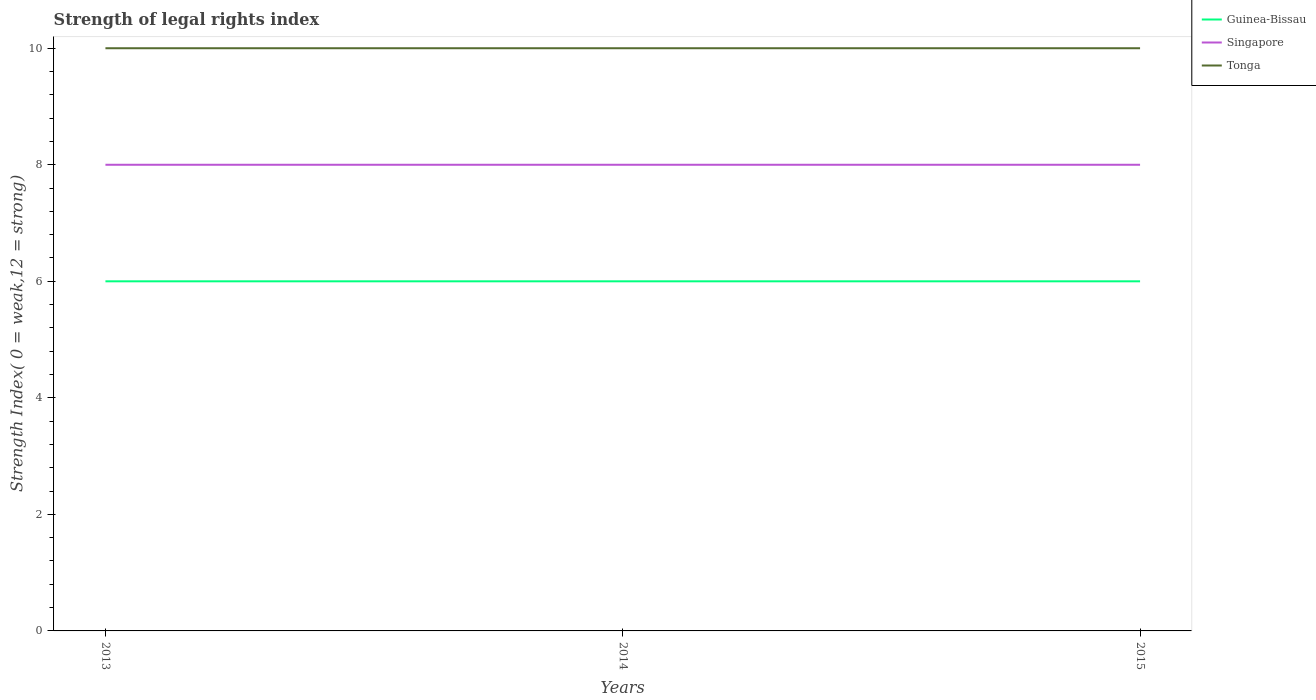Does the line corresponding to Singapore intersect with the line corresponding to Tonga?
Provide a succinct answer. No. Is the number of lines equal to the number of legend labels?
Your answer should be very brief. Yes. What is the difference between the highest and the lowest strength index in Tonga?
Give a very brief answer. 0. Is the strength index in Singapore strictly greater than the strength index in Guinea-Bissau over the years?
Ensure brevity in your answer.  No. What is the difference between two consecutive major ticks on the Y-axis?
Keep it short and to the point. 2. Are the values on the major ticks of Y-axis written in scientific E-notation?
Provide a short and direct response. No. Does the graph contain any zero values?
Give a very brief answer. No. Where does the legend appear in the graph?
Provide a succinct answer. Top right. How are the legend labels stacked?
Make the answer very short. Vertical. What is the title of the graph?
Provide a short and direct response. Strength of legal rights index. Does "Latin America(developing only)" appear as one of the legend labels in the graph?
Provide a short and direct response. No. What is the label or title of the Y-axis?
Offer a terse response. Strength Index( 0 = weak,12 = strong). What is the Strength Index( 0 = weak,12 = strong) of Singapore in 2013?
Your answer should be very brief. 8. What is the Strength Index( 0 = weak,12 = strong) in Singapore in 2014?
Your response must be concise. 8. What is the Strength Index( 0 = weak,12 = strong) of Singapore in 2015?
Offer a terse response. 8. Across all years, what is the maximum Strength Index( 0 = weak,12 = strong) in Singapore?
Make the answer very short. 8. Across all years, what is the maximum Strength Index( 0 = weak,12 = strong) in Tonga?
Offer a terse response. 10. Across all years, what is the minimum Strength Index( 0 = weak,12 = strong) in Guinea-Bissau?
Your answer should be very brief. 6. Across all years, what is the minimum Strength Index( 0 = weak,12 = strong) in Singapore?
Offer a very short reply. 8. What is the total Strength Index( 0 = weak,12 = strong) in Guinea-Bissau in the graph?
Provide a short and direct response. 18. What is the difference between the Strength Index( 0 = weak,12 = strong) of Guinea-Bissau in 2013 and that in 2014?
Your answer should be very brief. 0. What is the difference between the Strength Index( 0 = weak,12 = strong) in Singapore in 2013 and that in 2014?
Ensure brevity in your answer.  0. What is the difference between the Strength Index( 0 = weak,12 = strong) of Guinea-Bissau in 2014 and that in 2015?
Provide a succinct answer. 0. What is the difference between the Strength Index( 0 = weak,12 = strong) in Guinea-Bissau in 2013 and the Strength Index( 0 = weak,12 = strong) in Singapore in 2014?
Your response must be concise. -2. What is the difference between the Strength Index( 0 = weak,12 = strong) in Guinea-Bissau in 2013 and the Strength Index( 0 = weak,12 = strong) in Tonga in 2014?
Offer a terse response. -4. What is the difference between the Strength Index( 0 = weak,12 = strong) in Guinea-Bissau in 2013 and the Strength Index( 0 = weak,12 = strong) in Singapore in 2015?
Ensure brevity in your answer.  -2. What is the difference between the Strength Index( 0 = weak,12 = strong) of Guinea-Bissau in 2013 and the Strength Index( 0 = weak,12 = strong) of Tonga in 2015?
Keep it short and to the point. -4. What is the difference between the Strength Index( 0 = weak,12 = strong) of Guinea-Bissau in 2014 and the Strength Index( 0 = weak,12 = strong) of Singapore in 2015?
Your answer should be compact. -2. What is the difference between the Strength Index( 0 = weak,12 = strong) of Guinea-Bissau in 2014 and the Strength Index( 0 = weak,12 = strong) of Tonga in 2015?
Give a very brief answer. -4. What is the average Strength Index( 0 = weak,12 = strong) in Tonga per year?
Provide a succinct answer. 10. In the year 2013, what is the difference between the Strength Index( 0 = weak,12 = strong) of Guinea-Bissau and Strength Index( 0 = weak,12 = strong) of Singapore?
Provide a succinct answer. -2. In the year 2014, what is the difference between the Strength Index( 0 = weak,12 = strong) of Singapore and Strength Index( 0 = weak,12 = strong) of Tonga?
Make the answer very short. -2. In the year 2015, what is the difference between the Strength Index( 0 = weak,12 = strong) of Guinea-Bissau and Strength Index( 0 = weak,12 = strong) of Singapore?
Your response must be concise. -2. What is the ratio of the Strength Index( 0 = weak,12 = strong) in Guinea-Bissau in 2013 to that in 2014?
Offer a very short reply. 1. What is the ratio of the Strength Index( 0 = weak,12 = strong) in Tonga in 2013 to that in 2015?
Ensure brevity in your answer.  1. What is the ratio of the Strength Index( 0 = weak,12 = strong) in Guinea-Bissau in 2014 to that in 2015?
Offer a very short reply. 1. What is the ratio of the Strength Index( 0 = weak,12 = strong) of Tonga in 2014 to that in 2015?
Ensure brevity in your answer.  1. What is the difference between the highest and the lowest Strength Index( 0 = weak,12 = strong) of Guinea-Bissau?
Give a very brief answer. 0. What is the difference between the highest and the lowest Strength Index( 0 = weak,12 = strong) of Singapore?
Your answer should be compact. 0. 